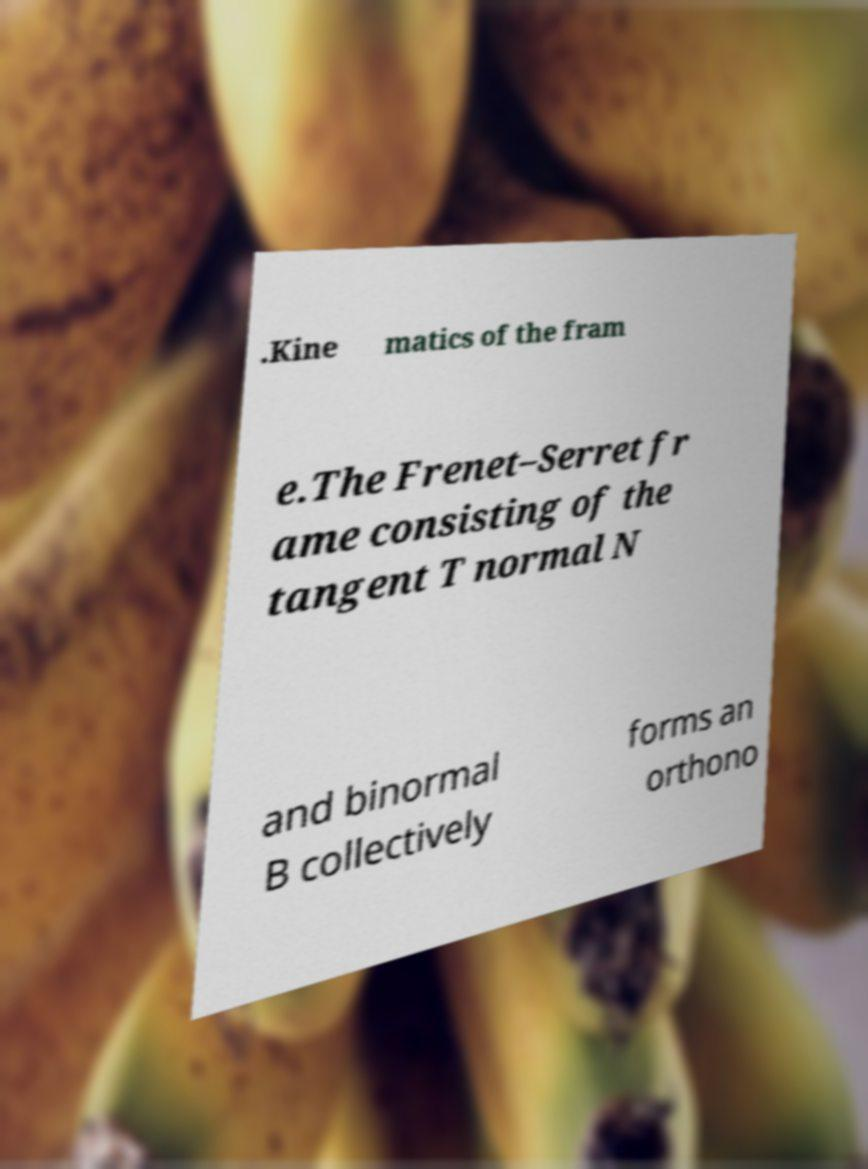Could you extract and type out the text from this image? .Kine matics of the fram e.The Frenet–Serret fr ame consisting of the tangent T normal N and binormal B collectively forms an orthono 